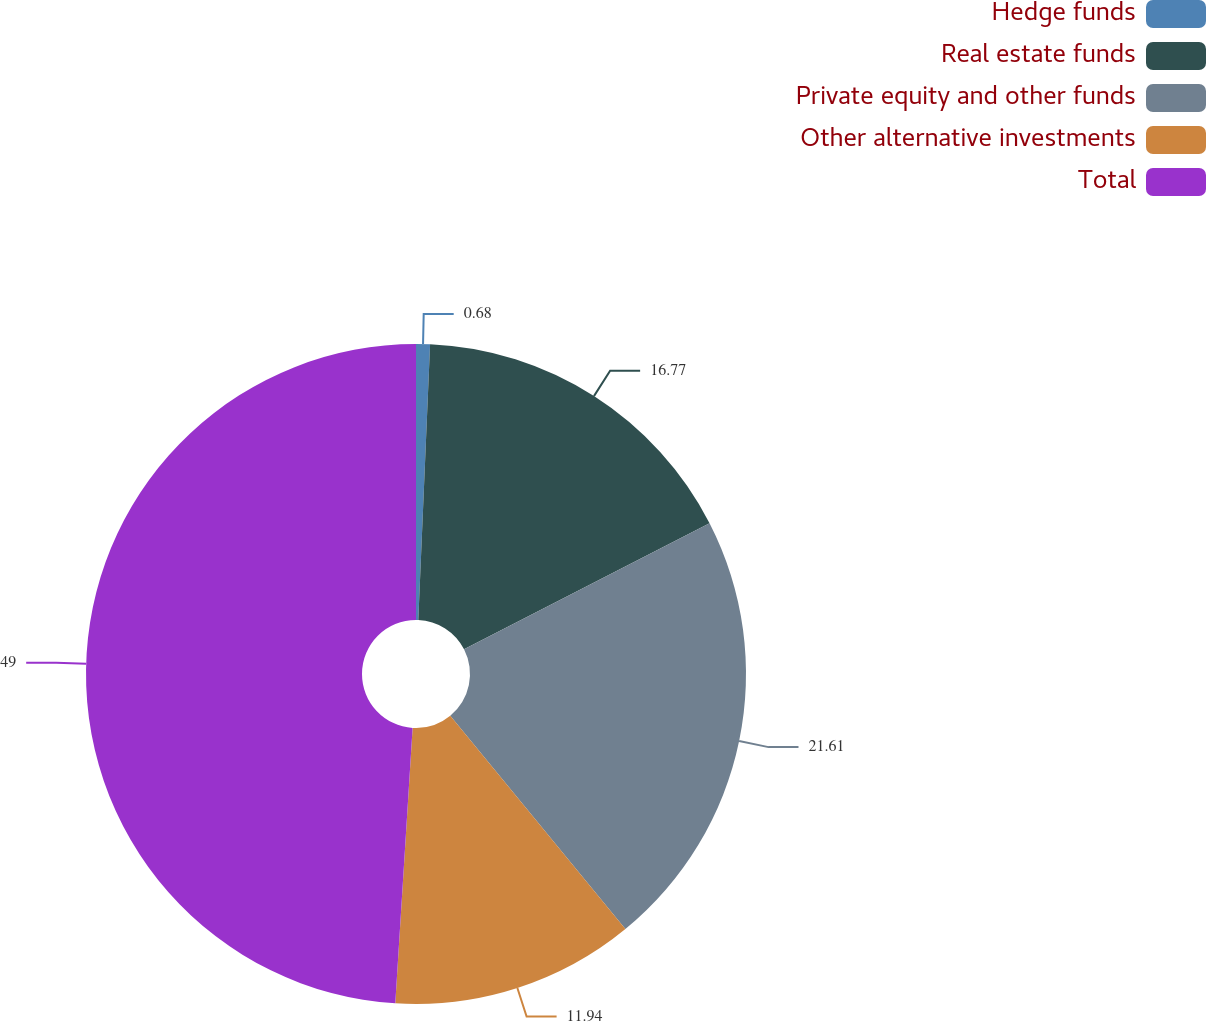Convert chart to OTSL. <chart><loc_0><loc_0><loc_500><loc_500><pie_chart><fcel>Hedge funds<fcel>Real estate funds<fcel>Private equity and other funds<fcel>Other alternative investments<fcel>Total<nl><fcel>0.68%<fcel>16.77%<fcel>21.61%<fcel>11.94%<fcel>49.0%<nl></chart> 